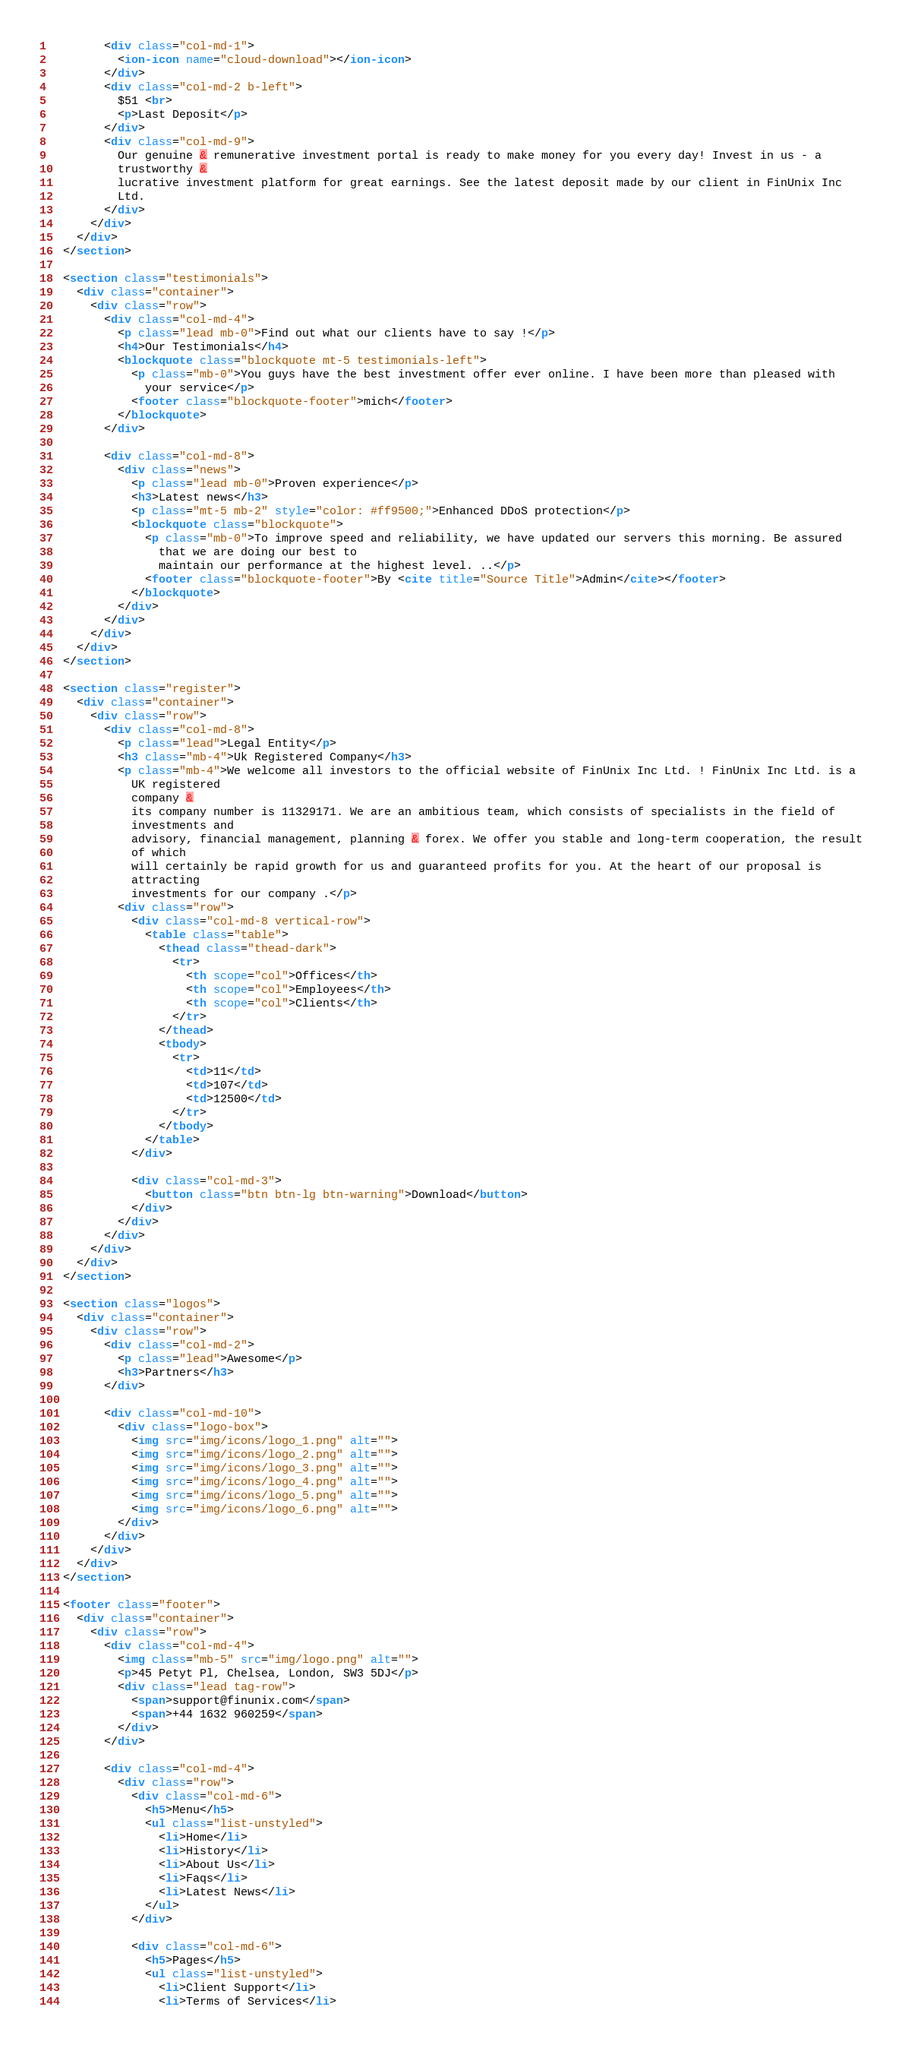Convert code to text. <code><loc_0><loc_0><loc_500><loc_500><_HTML_>        <div class="col-md-1">
          <ion-icon name="cloud-download"></ion-icon>
        </div>
        <div class="col-md-2 b-left">
          $51 <br>
          <p>Last Deposit</p>
        </div>
        <div class="col-md-9">
          Our genuine & remunerative investment portal is ready to make money for you every day! Invest in us - a
          trustworthy &
          lucrative investment platform for great earnings. See the latest deposit made by our client in FinUnix Inc
          Ltd.
        </div>
      </div>
    </div>
  </section>

  <section class="testimonials">
    <div class="container">
      <div class="row">
        <div class="col-md-4">
          <p class="lead mb-0">Find out what our clients have to say !</p>
          <h4>Our Testimonials</h4>
          <blockquote class="blockquote mt-5 testimonials-left">
            <p class="mb-0">You guys have the best investment offer ever online. I have been more than pleased with
              your service</p>
            <footer class="blockquote-footer">mich</footer>
          </blockquote>
        </div>

        <div class="col-md-8">
          <div class="news">
            <p class="lead mb-0">Proven experience</p>
            <h3>Latest news</h3>
            <p class="mt-5 mb-2" style="color: #ff9500;">Enhanced DDoS protection</p>
            <blockquote class="blockquote">
              <p class="mb-0">To improve speed and reliability, we have updated our servers this morning. Be assured
                that we are doing our best to
                maintain our performance at the highest level. ..</p>
              <footer class="blockquote-footer">By <cite title="Source Title">Admin</cite></footer>
            </blockquote>
          </div>
        </div>
      </div>
    </div>
  </section>

  <section class="register">
    <div class="container">
      <div class="row">
        <div class="col-md-8">
          <p class="lead">Legal Entity</p>
          <h3 class="mb-4">Uk Registered Company</h3>
          <p class="mb-4">We welcome all investors to the official website of FinUnix Inc Ltd. ! FinUnix Inc Ltd. is a
            UK registered
            company &
            its company number is 11329171. We are an ambitious team, which consists of specialists in the field of
            investments and
            advisory, financial management, planning & forex. We offer you stable and long-term cooperation, the result
            of which
            will certainly be rapid growth for us and guaranteed profits for you. At the heart of our proposal is
            attracting
            investments for our company .</p>
          <div class="row">
            <div class="col-md-8 vertical-row">
              <table class="table">
                <thead class="thead-dark">
                  <tr>
                    <th scope="col">Offices</th>
                    <th scope="col">Employees</th>
                    <th scope="col">Clients</th>
                  </tr>
                </thead>
                <tbody>
                  <tr>
                    <td>11</td>
                    <td>107</td>
                    <td>12500</td>
                  </tr>
                </tbody>
              </table>
            </div>

            <div class="col-md-3">
              <button class="btn btn-lg btn-warning">Download</button>
            </div>
          </div>
        </div>
      </div>
    </div>
  </section>

  <section class="logos">
    <div class="container">
      <div class="row">
        <div class="col-md-2">
          <p class="lead">Awesome</p>
          <h3>Partners</h3>
        </div>

        <div class="col-md-10">
          <div class="logo-box">
            <img src="img/icons/logo_1.png" alt="">
            <img src="img/icons/logo_2.png" alt="">
            <img src="img/icons/logo_3.png" alt="">
            <img src="img/icons/logo_4.png" alt="">
            <img src="img/icons/logo_5.png" alt="">
            <img src="img/icons/logo_6.png" alt="">
          </div>
        </div>
      </div>
    </div>
  </section>

  <footer class="footer">
    <div class="container">
      <div class="row">
        <div class="col-md-4">
          <img class="mb-5" src="img/logo.png" alt="">
          <p>45 Petyt Pl, Chelsea, London, SW3 5DJ</p>
          <div class="lead tag-row">
            <span>support@finunix.com</span>
            <span>+44 1632 960259</span>
          </div>
        </div>

        <div class="col-md-4">
          <div class="row">
            <div class="col-md-6">
              <h5>Menu</h5>
              <ul class="list-unstyled">
                <li>Home</li>
                <li>History</li>
                <li>About Us</li>
                <li>Faqs</li>
                <li>Latest News</li>
              </ul>
            </div>

            <div class="col-md-6">
              <h5>Pages</h5>
              <ul class="list-unstyled">
                <li>Client Support</li>
                <li>Terms of Services</li></code> 